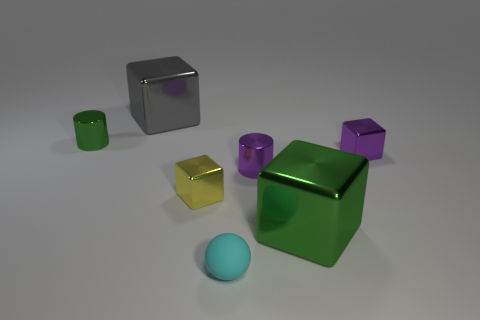Add 1 big metallic things. How many objects exist? 8 Subtract all blocks. How many objects are left? 3 Add 1 big cubes. How many big cubes exist? 3 Subtract 0 yellow spheres. How many objects are left? 7 Subtract all small yellow metallic things. Subtract all purple shiny blocks. How many objects are left? 5 Add 6 green metallic cylinders. How many green metallic cylinders are left? 7 